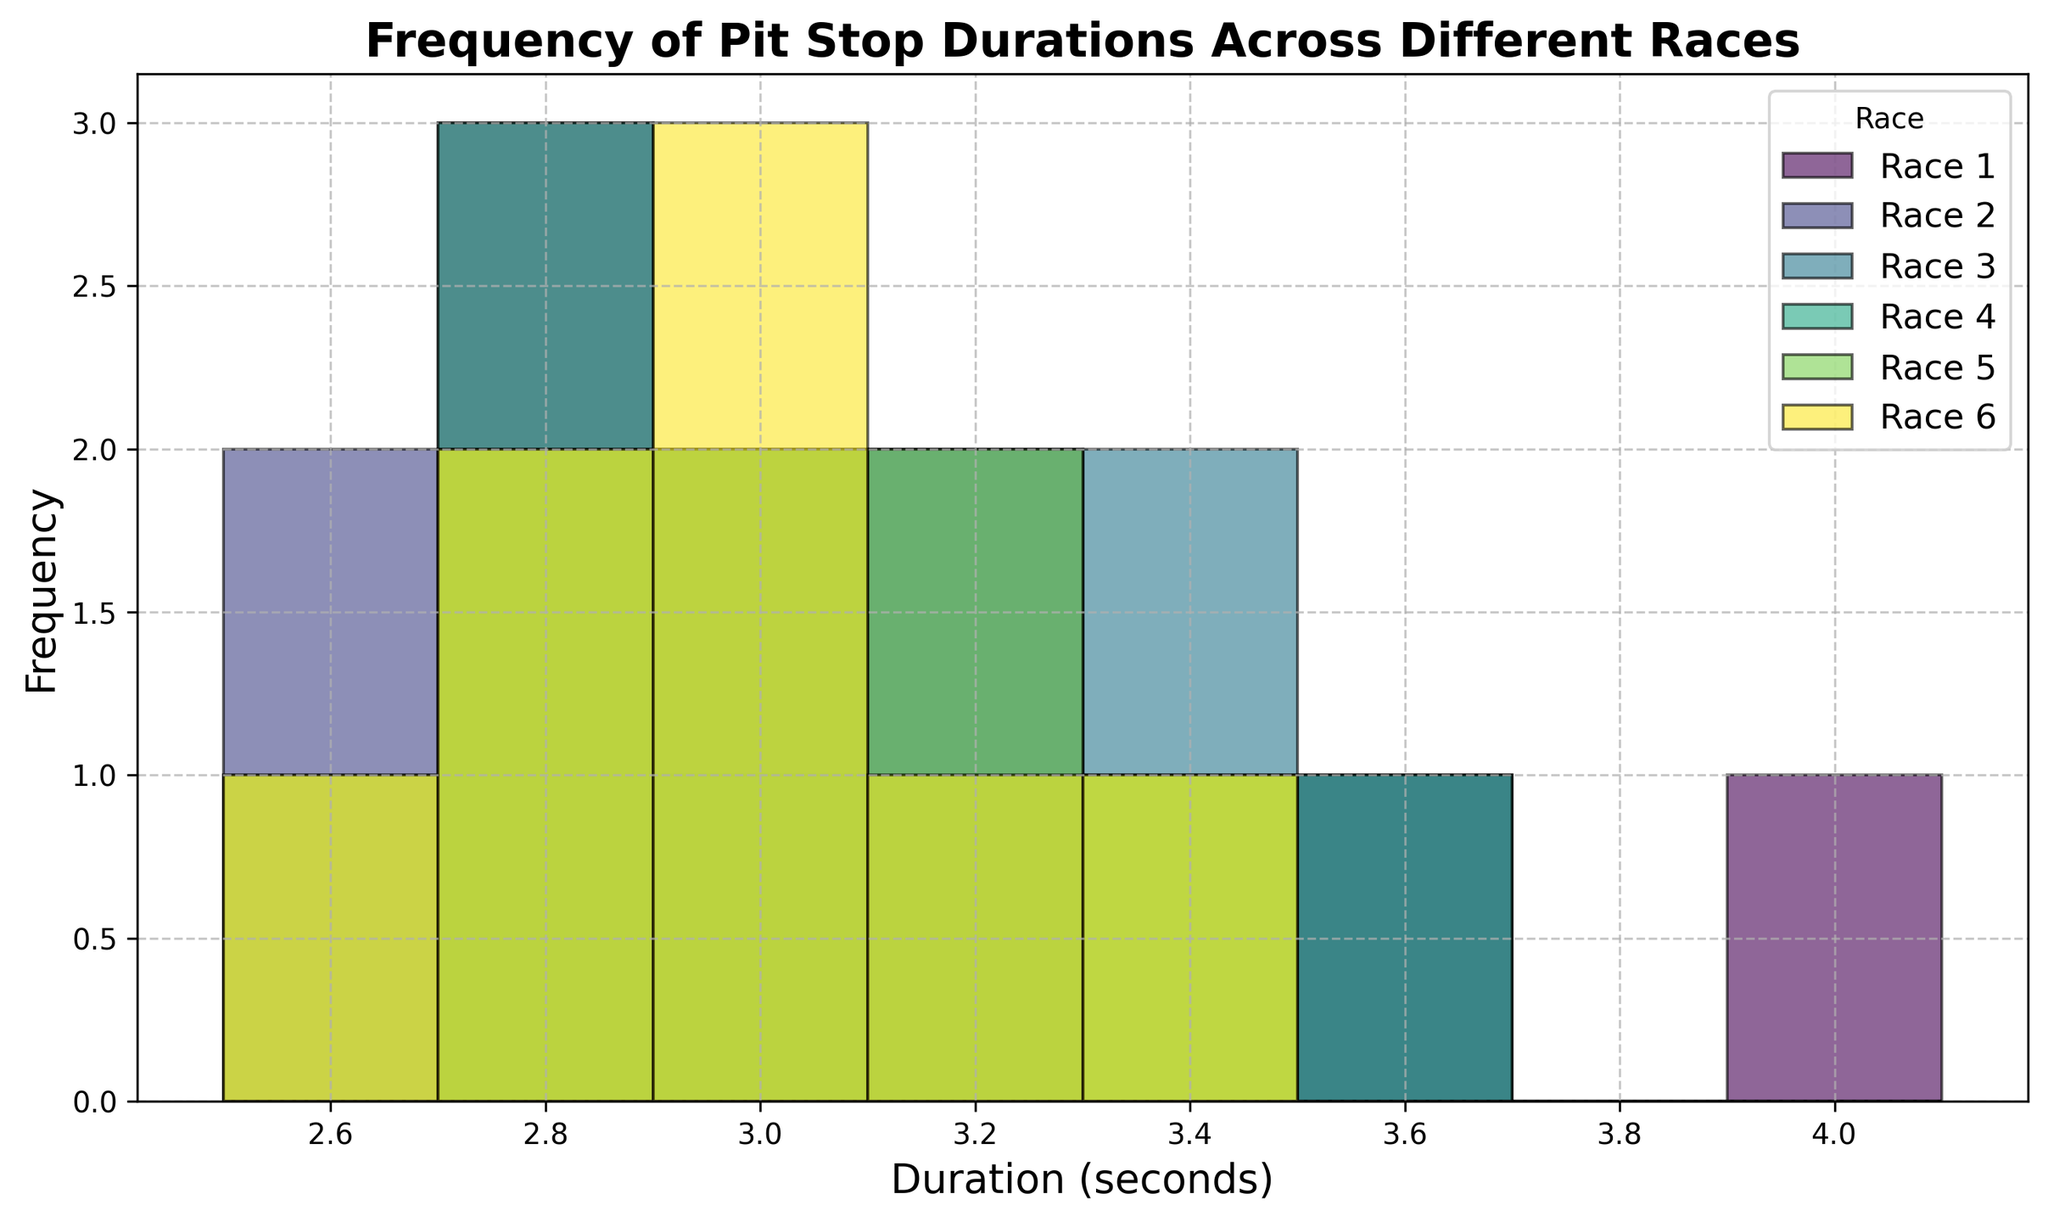Compare the frequency of pit stop durations of Race 1 and Race 2 in the 2.9-3.1 seconds range. Look at the histogram and identify the bars that represent durations between 2.9 and 3.1 seconds for both Race 1 and Race 2. Count the heights of these bars for both races.
Answer: Race 1: 2; Race 2: 2 Which race has the highest peak frequency? Identify the race with the tallest bar in the histogram, regardless of the duration value it corresponds to.
Answer: Race 2 How does the distribution of pit stop durations in Race 3 compare to Race 5? Examine the shapes and spread of the histograms for Race 3 and Race 5. Note the range of values and the frequency of pit stops at those values.
Answer: Both are similar in spread, with peaks around 3.0-3.5 seconds What is the most common pit stop duration in Race 4? Identify the tallest bar in the histogram for Race 4 and note the duration value it represents.
Answer: 3.0-3.2 seconds range Are there any pit stop durations that are unique to a specific race? Check each histogram for any bars that appear in one race's histogram but not in the others.
Answer: Yes, 4.1 seconds only in Race 1 How does the pit stop duration range for Race 6 differ from Race 1? Compare the ranges of pit stop durations for Race 6 and Race 1 by looking at the spread of their respective histograms.
Answer: Race 6 has 2.6-3.5 seconds; Race 1 has 2.7-4.1 seconds What is the least common pit stop duration across all races? Identify the shortest bar across all histograms and determine the corresponding duration value.
Answer: 4.1 seconds Which race has the pit stop duration with the least variation in frequency? Look for a histogram where the bars are all roughly the same height, indicating little variation in pit stop times.
Answer: Race 4 Is there any overlap in the pit stop duration ranges for all the races? Determine if there is a common duration range that appears in all the histograms.
Answer: Yes, 2.7-3.3 seconds 